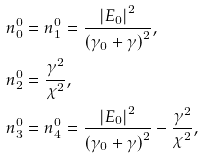Convert formula to latex. <formula><loc_0><loc_0><loc_500><loc_500>& n _ { 0 } ^ { 0 } = n _ { 1 } ^ { 0 } = \frac { \left | E _ { 0 } \right | ^ { 2 } } { \left ( \gamma _ { 0 } + \gamma \right ) ^ { 2 } } , \\ & n _ { 2 } ^ { 0 } = \frac { \gamma ^ { 2 } } { \chi ^ { 2 } } , \\ & n _ { 3 } ^ { 0 } = n _ { 4 } ^ { 0 } = \frac { \left | E _ { 0 } \right | ^ { 2 } } { \left ( \gamma _ { 0 } + \gamma \right ) ^ { 2 } } - \frac { \gamma ^ { 2 } } { \chi ^ { 2 } } ,</formula> 